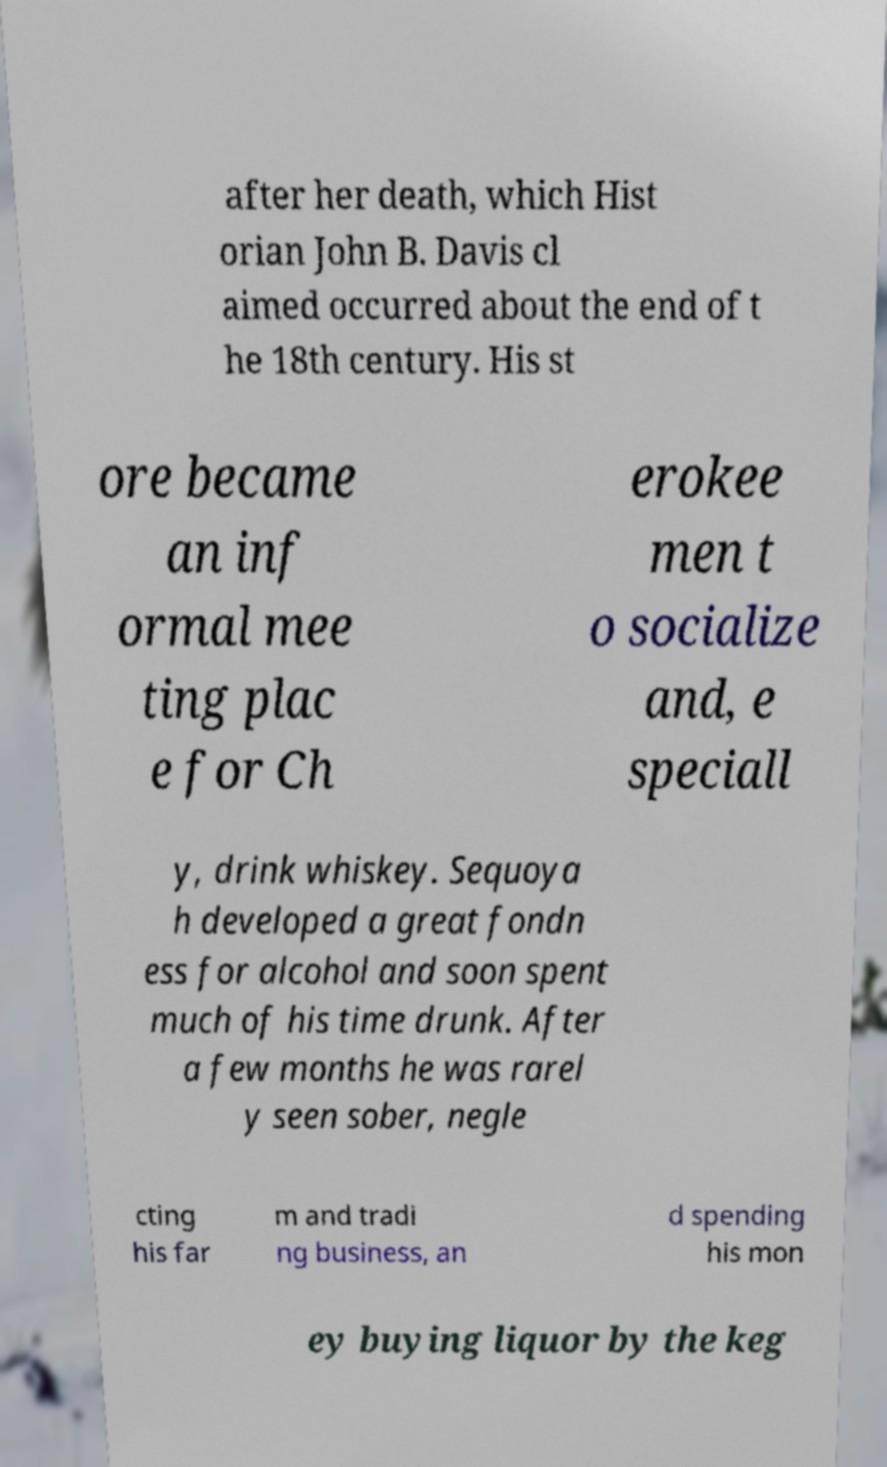For documentation purposes, I need the text within this image transcribed. Could you provide that? after her death, which Hist orian John B. Davis cl aimed occurred about the end of t he 18th century. His st ore became an inf ormal mee ting plac e for Ch erokee men t o socialize and, e speciall y, drink whiskey. Sequoya h developed a great fondn ess for alcohol and soon spent much of his time drunk. After a few months he was rarel y seen sober, negle cting his far m and tradi ng business, an d spending his mon ey buying liquor by the keg 